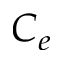<formula> <loc_0><loc_0><loc_500><loc_500>C _ { e }</formula> 